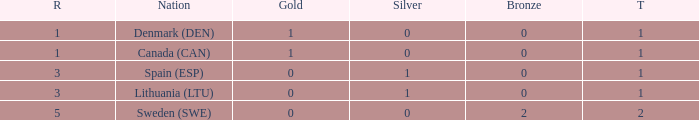How many bronze medals were won when the total is more than 1, and gold is more than 0? None. 